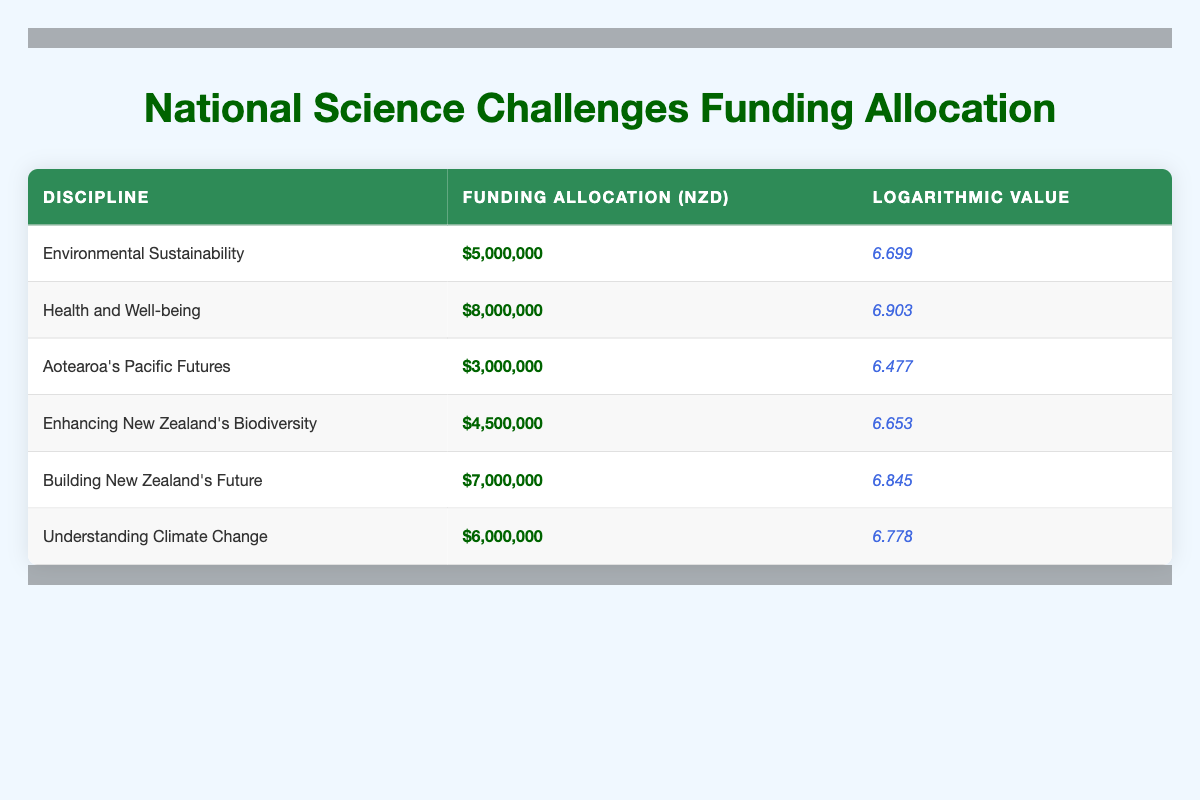What is the funding allocation for "Understanding Climate Change"? The table lists the funding allocation for "Understanding Climate Change" as $6,000,000. You can find this directly by locating the corresponding row for this discipline in the table.
Answer: $6,000,000 Which discipline has the highest funding allocation? By reviewing the funding allocations in the table, "Health and Well-being" has the highest allocation at $8,000,000. This can be confirmed by comparing all listed allocations in the relevant column.
Answer: $8,000,000 What is the logarithmic value for "Aotearoa's Pacific Futures"? The table shows that the logarithmic value for "Aotearoa's Pacific Futures" is 6.477. This is found in the row corresponding to this discipline.
Answer: 6.477 What is the total funding allocation for the disciplines related to environmental and climate challenges? The relevant disciplines are "Environmental Sustainability" with $5,000,000 and "Understanding Climate Change" with $6,000,000. Summing these gives $5,000,000 + $6,000,000 = $11,000,000, which represents the combined funding allocation for these two areas.
Answer: $11,000,000 Is the funding allocation for "Building New Zealand's Future" more than $5,000,000? The allocation for this discipline is $7,000,000, which is indeed more than $5,000,000. This can be confirmed by checking the specific allocation listed in the table.
Answer: Yes What is the average funding allocation for all the disciplines listed? To calculate the average, sum all funding allocations: $5,000,000 + $8,000,000 + $3,000,000 + $4,500,000 + $7,000,000 + $6,000,000 = $33,500,000. Since there are 6 disciplines, the average is $33,500,000 / 6 = $5,583,333.33. Thus, the average funding allocation can be determined by dividing the total by the number of disciplines.
Answer: $5,583,333.33 Which discipline has a logarithmic value closest to 6.7? Reviewing the logarithmic values, "Environmental Sustainability" has a logarithmic value of 6.699, which is closest to 6.7 when compared to others. This determination requires examining all logarithmic values in the table.
Answer: Environmental Sustainability How many disciplines have a funding allocation of less than $5,000,000? The table indicates that only "Aotearoa's Pacific Futures" has a funding allocation less than $5,000,000, which is $3,000,000. To answer this, simply count the disciplines below that threshold.
Answer: 1 